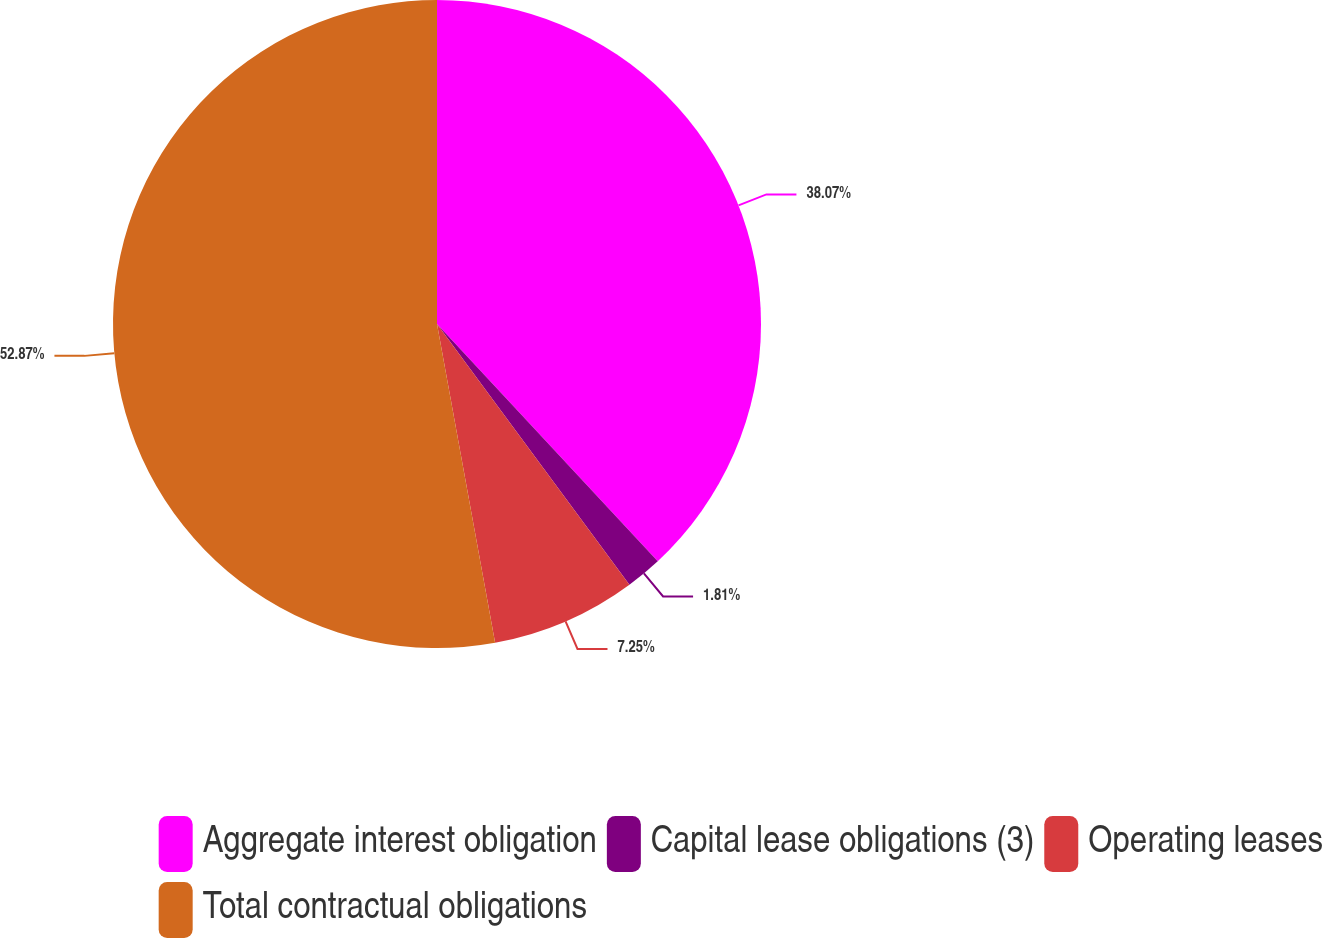<chart> <loc_0><loc_0><loc_500><loc_500><pie_chart><fcel>Aggregate interest obligation<fcel>Capital lease obligations (3)<fcel>Operating leases<fcel>Total contractual obligations<nl><fcel>38.07%<fcel>1.81%<fcel>7.25%<fcel>52.87%<nl></chart> 